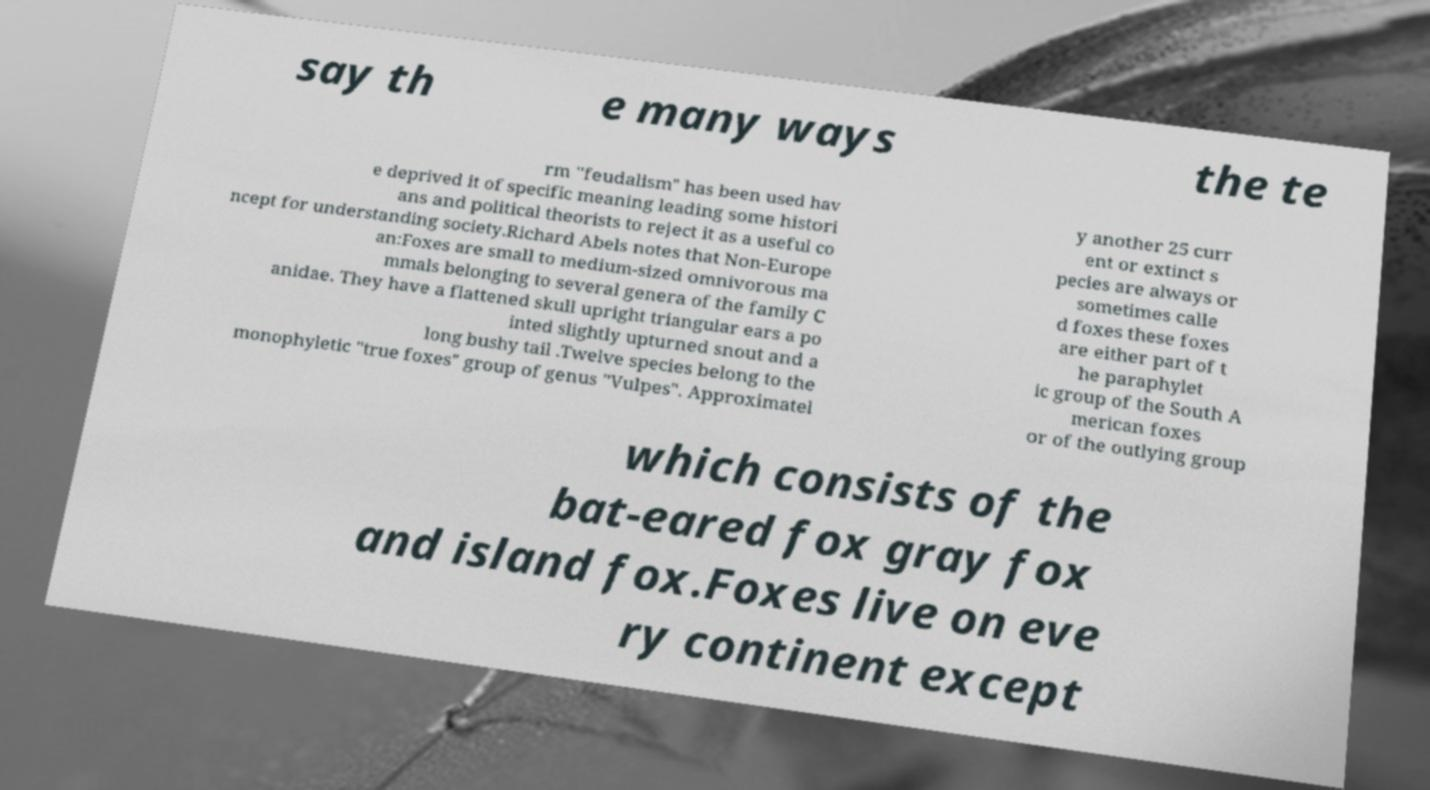Can you accurately transcribe the text from the provided image for me? say th e many ways the te rm "feudalism" has been used hav e deprived it of specific meaning leading some histori ans and political theorists to reject it as a useful co ncept for understanding society.Richard Abels notes that Non-Europe an:Foxes are small to medium-sized omnivorous ma mmals belonging to several genera of the family C anidae. They have a flattened skull upright triangular ears a po inted slightly upturned snout and a long bushy tail .Twelve species belong to the monophyletic "true foxes" group of genus "Vulpes". Approximatel y another 25 curr ent or extinct s pecies are always or sometimes calle d foxes these foxes are either part of t he paraphylet ic group of the South A merican foxes or of the outlying group which consists of the bat-eared fox gray fox and island fox.Foxes live on eve ry continent except 